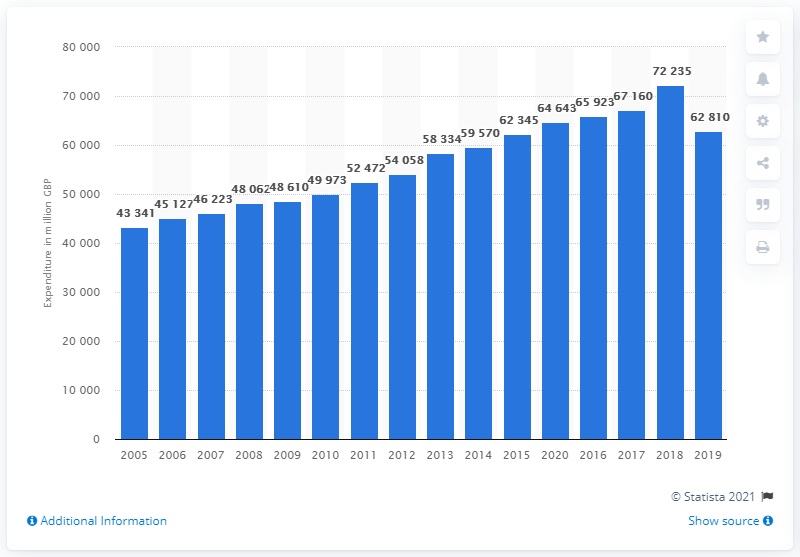What trends can be observed in the UK apparel and footwear market from this data? The data presents a generally upward trend in the UK's apparel and footwear market expenditure over the years, with some fluctuations. After a gradual rise in market value from 2005 to 2008, there is a significant increase from 2008 to 2014. The market appears to stabilize somewhat between 2014 and 2016 before experiencing another sharp rise in 2017, reaching its peak in 2018. A slight decrease can be observed in 2019. These trends could be influenced by various factors, including economic conditions, fashion trends, and consumer purchasing power. 